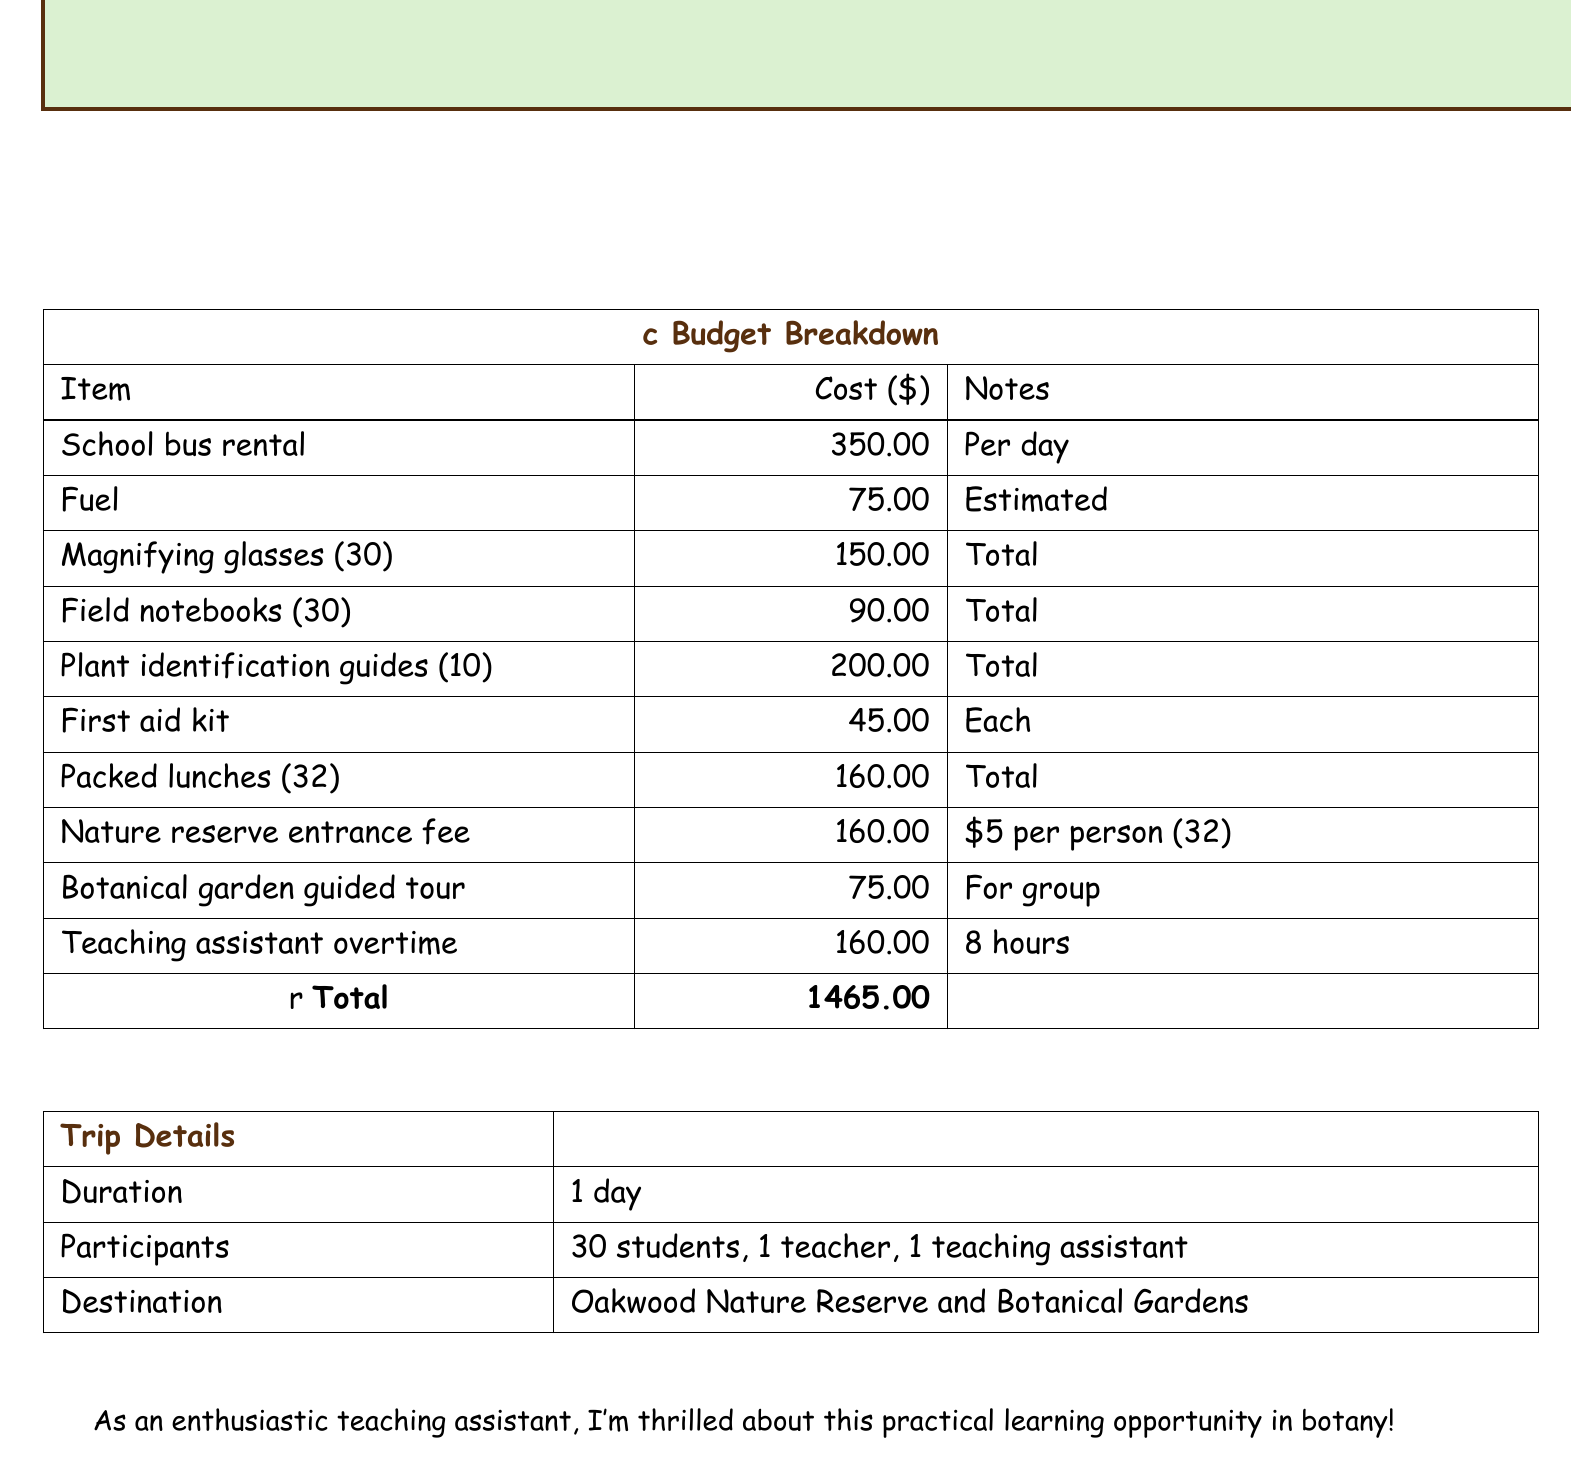What is the total cost of the field trip? The total cost is recorded last in the budget breakdown section.
Answer: 1465.00 How many students are participating in the trip? The number of students is mentioned in the trip details section.
Answer: 30 students What is the cost for the school bus rental? The cost for school bus rental is specified in the budget breakdown.
Answer: 350.00 How much do packed lunches cost in total? The total cost for packed lunches is given in the itemized budget.
Answer: 160.00 What is the duration of the trip? The duration of the trip is listed in the trip details section.
Answer: 1 day How much is the nature reserve entrance fee per person? The entrance fee per person is outlined in the budget details.
Answer: 5 per person What is included in the total number of participants? The total number of participants is specified to include students, a teacher, and a teaching assistant.
Answer: 30 students, 1 teacher, 1 teaching assistant What is the cost of the first aid kit? The budget outlines the cost for each first aid kit.
Answer: 45.00 How much is allocated for the botanical garden guided tour? The allocation for the guided tour is specified in the budget breakdown section.
Answer: 75.00 